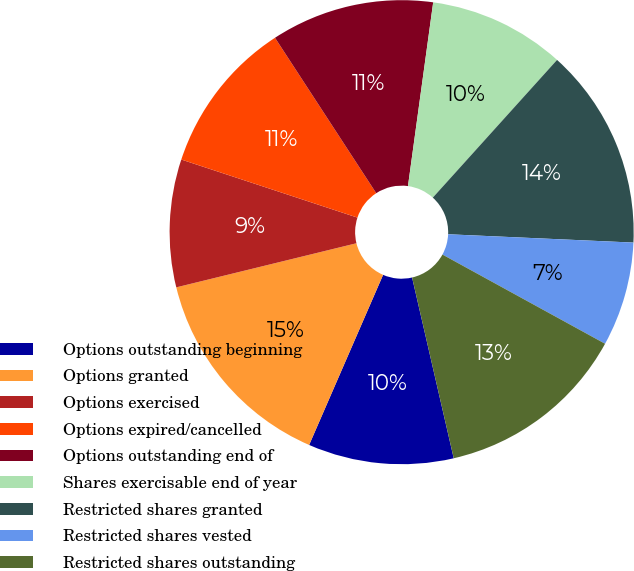Convert chart. <chart><loc_0><loc_0><loc_500><loc_500><pie_chart><fcel>Options outstanding beginning<fcel>Options granted<fcel>Options exercised<fcel>Options expired/cancelled<fcel>Options outstanding end of<fcel>Shares exercisable end of year<fcel>Restricted shares granted<fcel>Restricted shares vested<fcel>Restricted shares outstanding<nl><fcel>10.13%<fcel>14.65%<fcel>8.89%<fcel>10.74%<fcel>11.36%<fcel>9.51%<fcel>14.03%<fcel>7.27%<fcel>13.41%<nl></chart> 